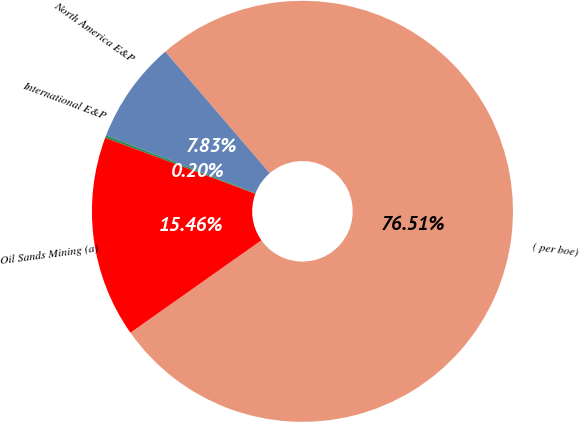Convert chart to OTSL. <chart><loc_0><loc_0><loc_500><loc_500><pie_chart><fcel>( per boe)<fcel>North America E&P<fcel>International E&P<fcel>Oil Sands Mining (a)<nl><fcel>76.52%<fcel>7.83%<fcel>0.2%<fcel>15.46%<nl></chart> 